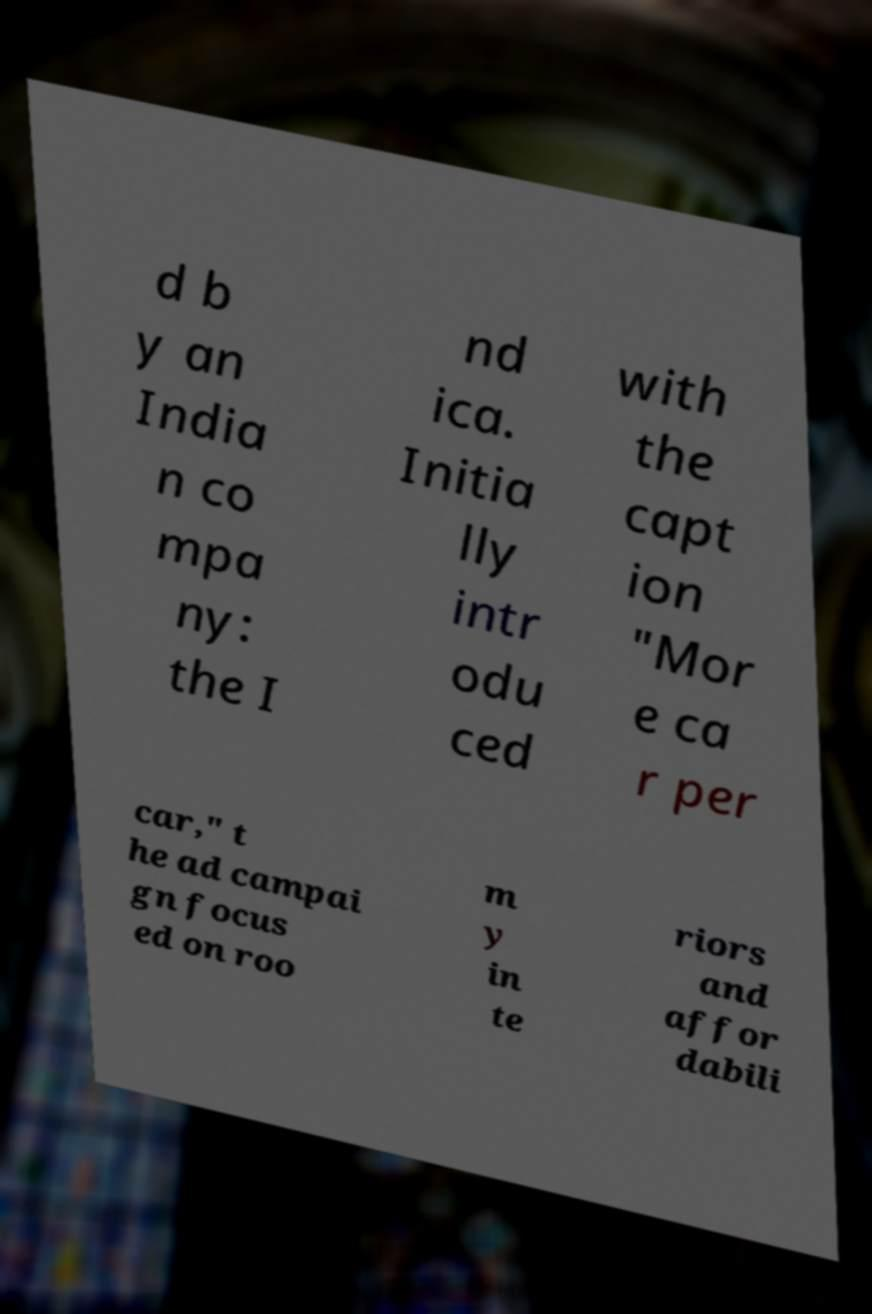Please read and relay the text visible in this image. What does it say? d b y an India n co mpa ny: the I nd ica. Initia lly intr odu ced with the capt ion "Mor e ca r per car," t he ad campai gn focus ed on roo m y in te riors and affor dabili 